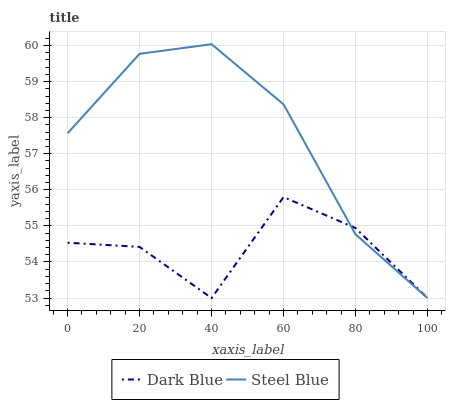Does Dark Blue have the minimum area under the curve?
Answer yes or no. Yes. Does Steel Blue have the maximum area under the curve?
Answer yes or no. Yes. Does Steel Blue have the minimum area under the curve?
Answer yes or no. No. Is Steel Blue the smoothest?
Answer yes or no. Yes. Is Dark Blue the roughest?
Answer yes or no. Yes. Is Steel Blue the roughest?
Answer yes or no. No. Does Dark Blue have the lowest value?
Answer yes or no. Yes. Does Steel Blue have the highest value?
Answer yes or no. Yes. Does Steel Blue intersect Dark Blue?
Answer yes or no. Yes. Is Steel Blue less than Dark Blue?
Answer yes or no. No. Is Steel Blue greater than Dark Blue?
Answer yes or no. No. 